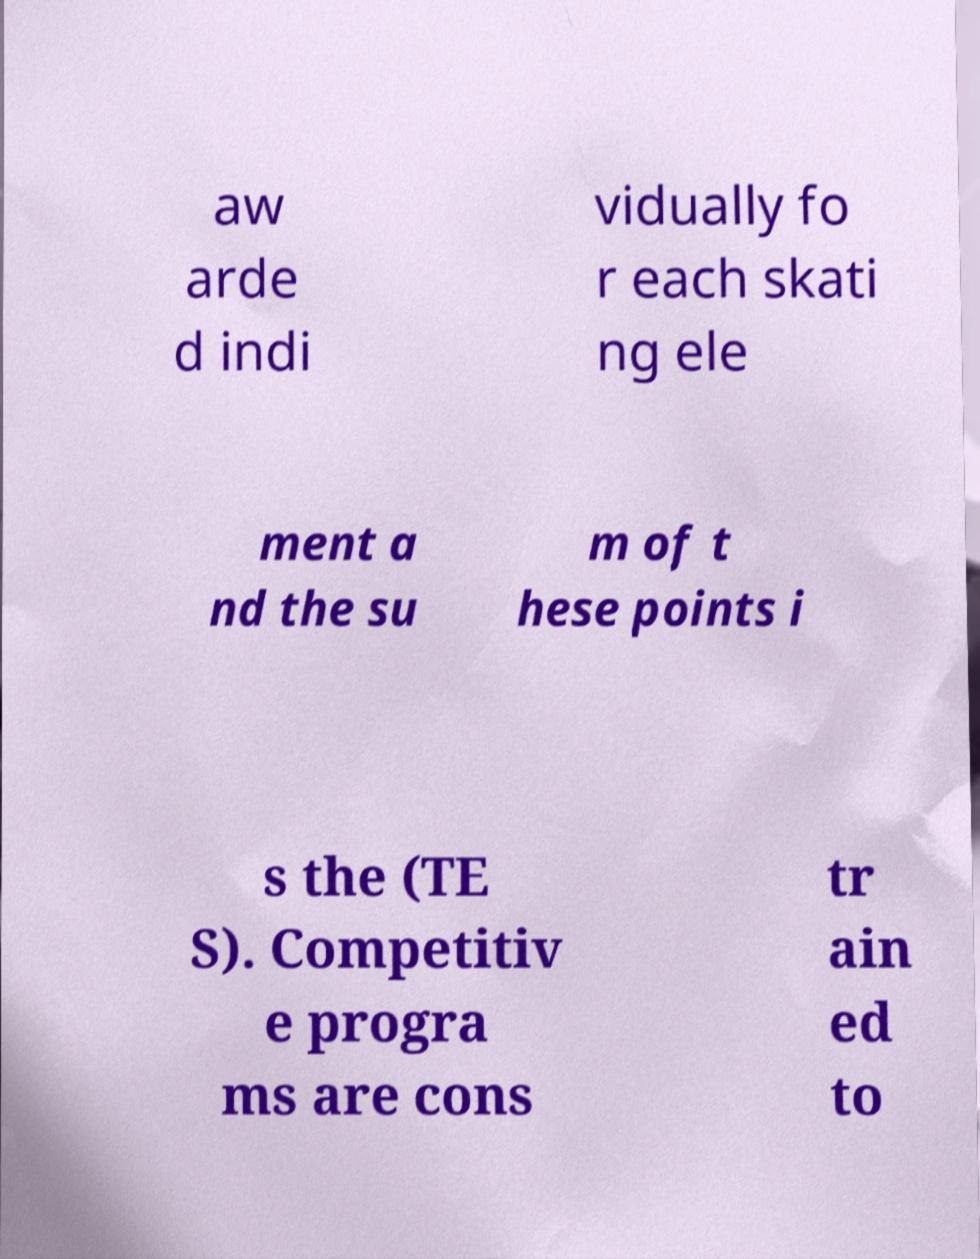What messages or text are displayed in this image? I need them in a readable, typed format. aw arde d indi vidually fo r each skati ng ele ment a nd the su m of t hese points i s the (TE S). Competitiv e progra ms are cons tr ain ed to 